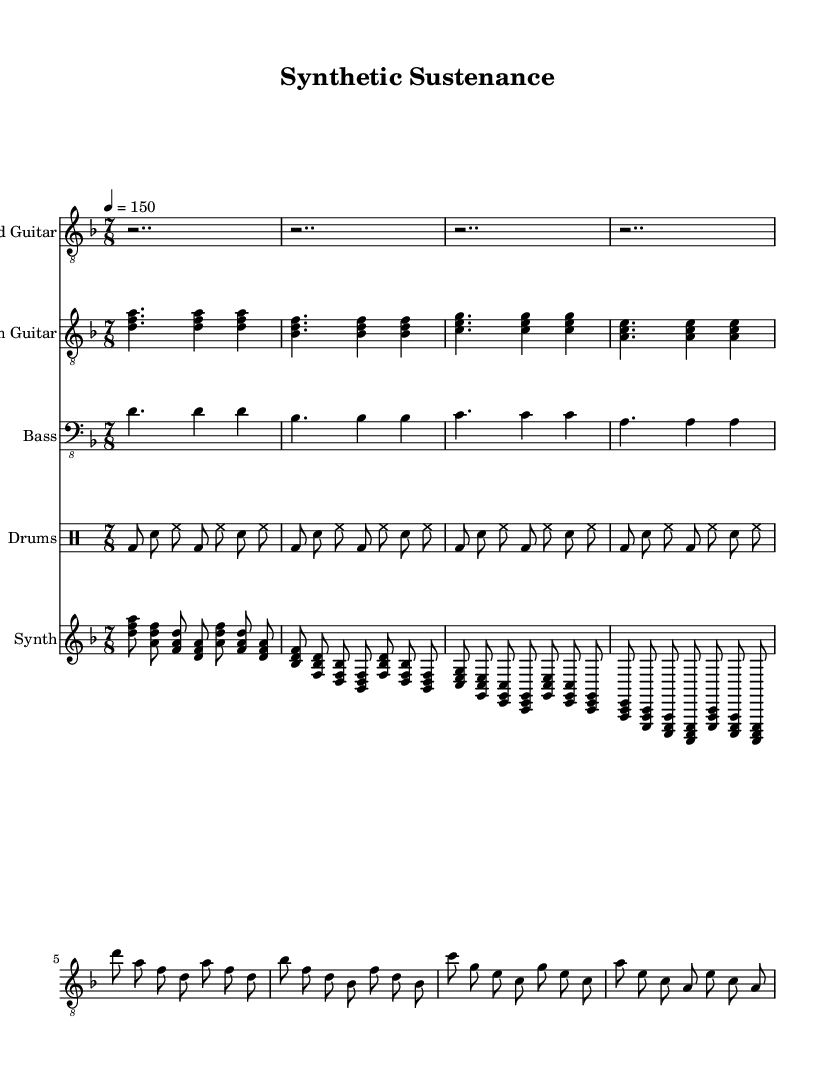What is the key signature of this music? The key signature is D minor, which has one flat (B flat). This can be determined by looking at the key signature indicated at the beginning of the score.
Answer: D minor What is the time signature of this music? The time signature is 7/8, meaning there are seven eighth notes in each measure. This is indicated at the beginning of the sheet music next to the key signature.
Answer: 7/8 What is the tempo marking in this score? The tempo marking is 150 beats per minute, indicated by the 'tempo' directive in the score. This tells musicians how fast to play the piece.
Answer: 150 How many measures are in the lead guitar part? The lead guitar part consists of four measures, which can be counted by looking at the notation in the score. Each set of notes corresponds to a measure, and the lead guitar part visually spans four of these.
Answer: 4 Which instrument plays the bass part? The bass part is played by the bass guitar. This can be inferred from the label at the start of the staff that shows it is designated for the bass guitar.
Answer: Bass guitar How many different instruments are featured in this score? The score features five different instruments: lead guitar, rhythm guitar, bass, drums, and synth. This is established by observing the individual staves labeled for each instrument.
Answer: 5 What type of rhythm does the drums section primarily utilize? The drums section primarily utilizes a combination of bass drum and snare drum along with hi-hat, which contributes to a driving rhythm typical in metal genres. This can be seen in the drum part notations which depict the sequence of these drum components.
Answer: Bass and snare 